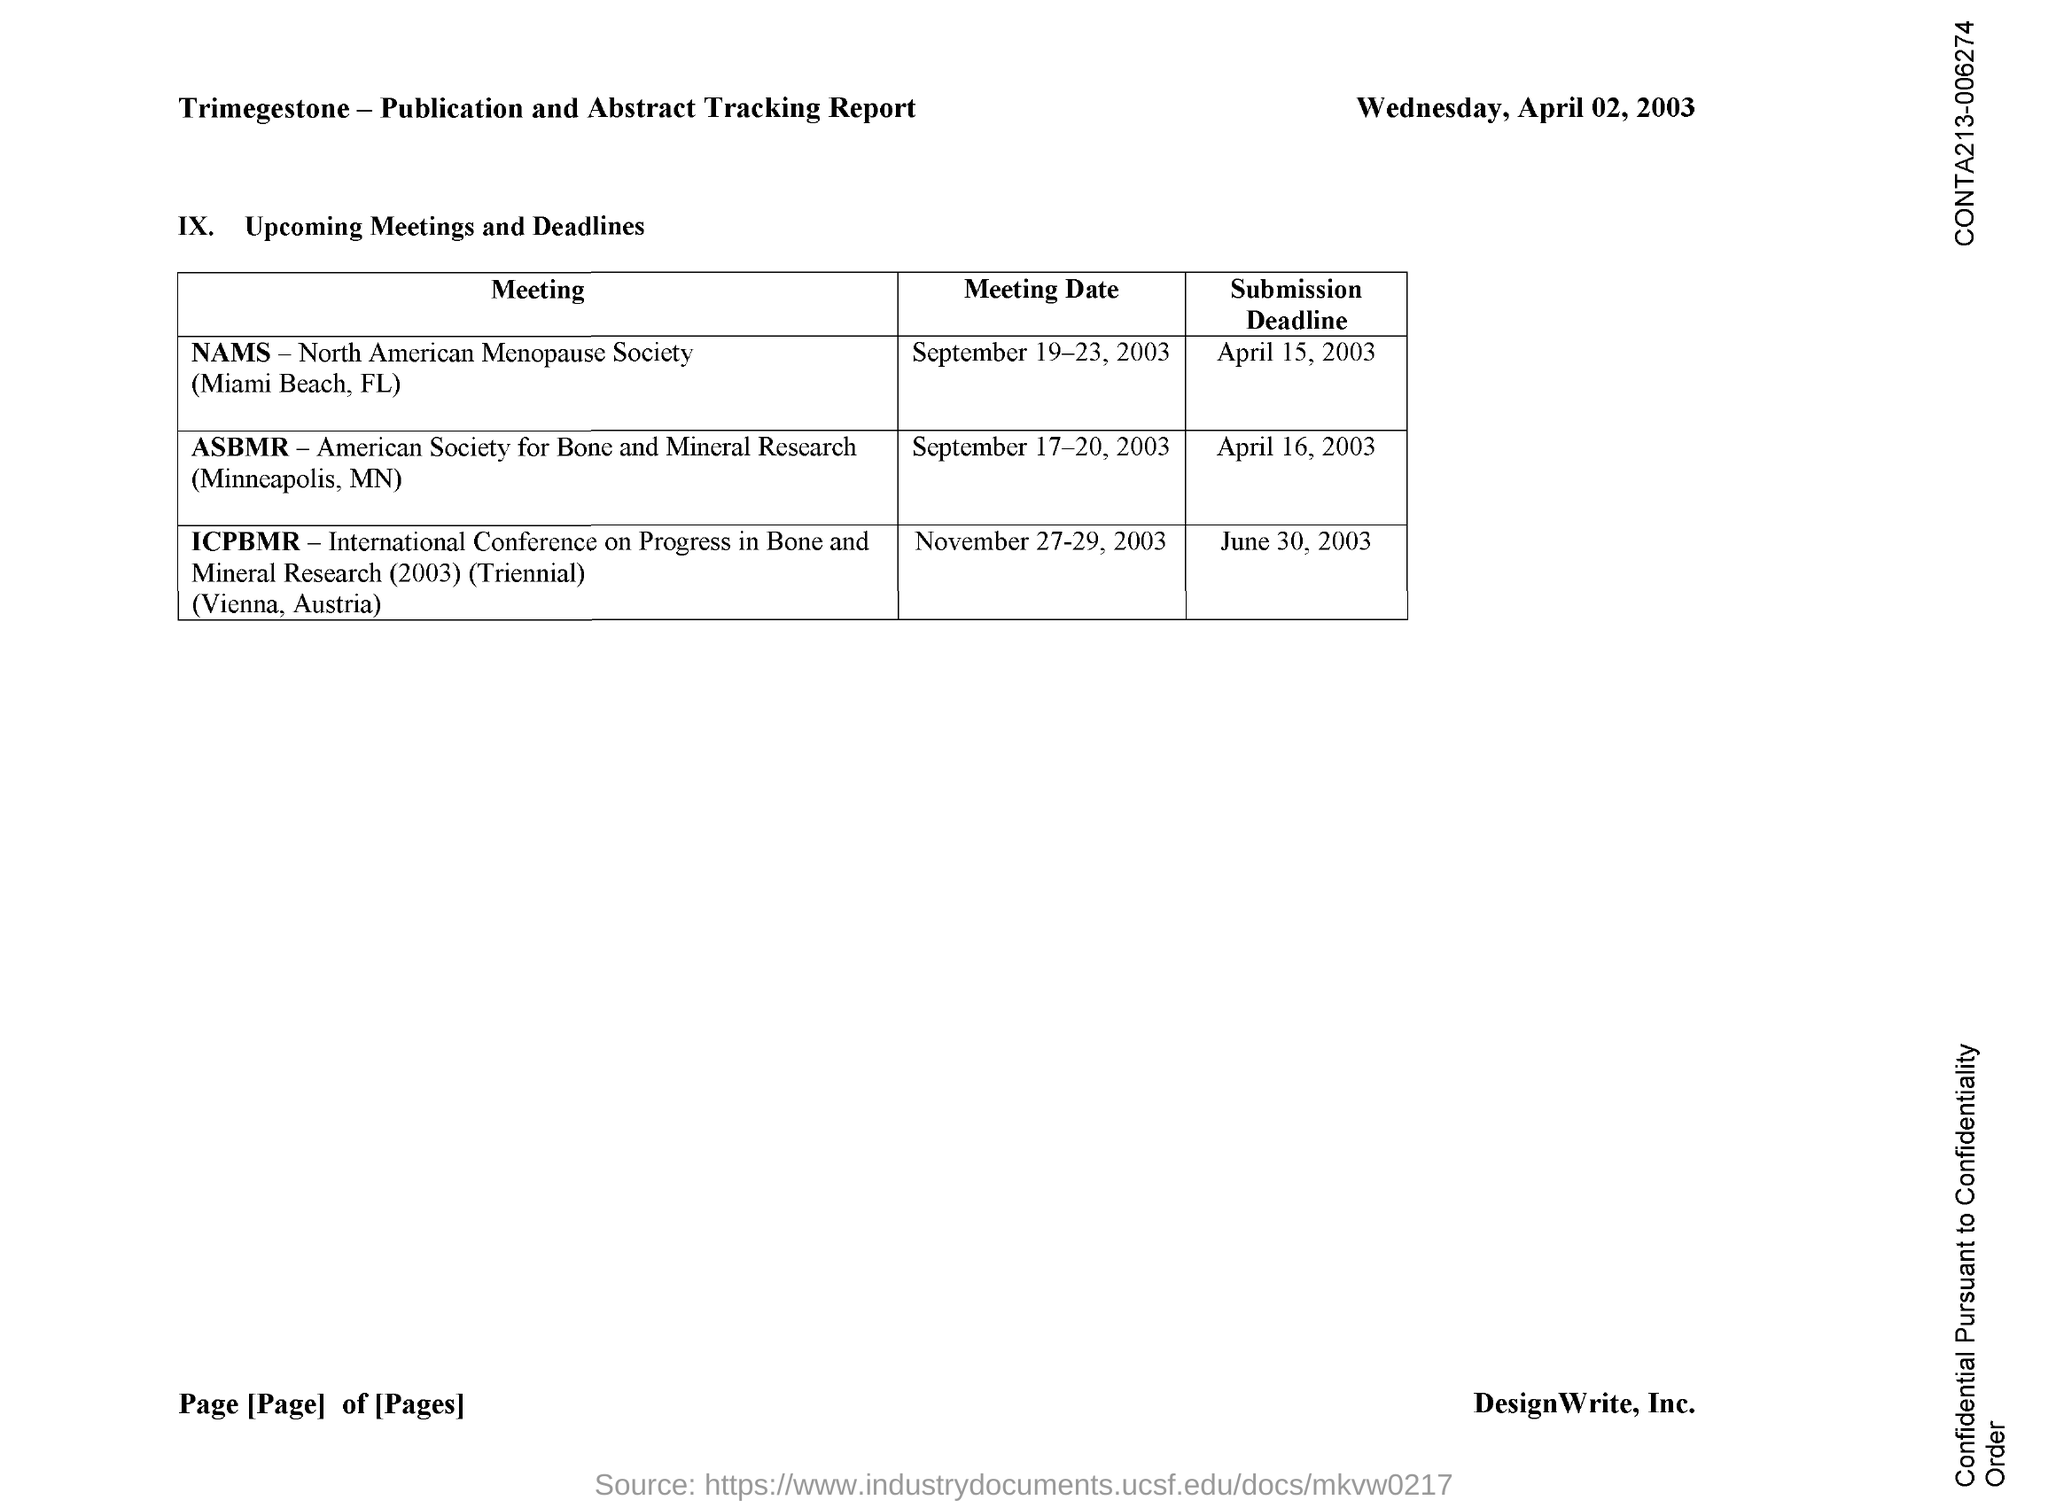On which date nams meeting was conducted ?
Your response must be concise. September 19-23 , 2003. What is the full form of asbmr ?
Offer a terse response. American Society for Bone and Mineral Research. On which date the asbmr meeting was conducted
Provide a succinct answer. September 17-20, 2003. What is the submission deadline date for the asbmr meeting ?
Provide a succinct answer. April 16,2003. On which date icpbmr meeting is conducted ?
Your answer should be very brief. November 27-29, 2003. What is the submission deadline date for icpbmr meeting ?
Provide a short and direct response. June 30, 2003. 